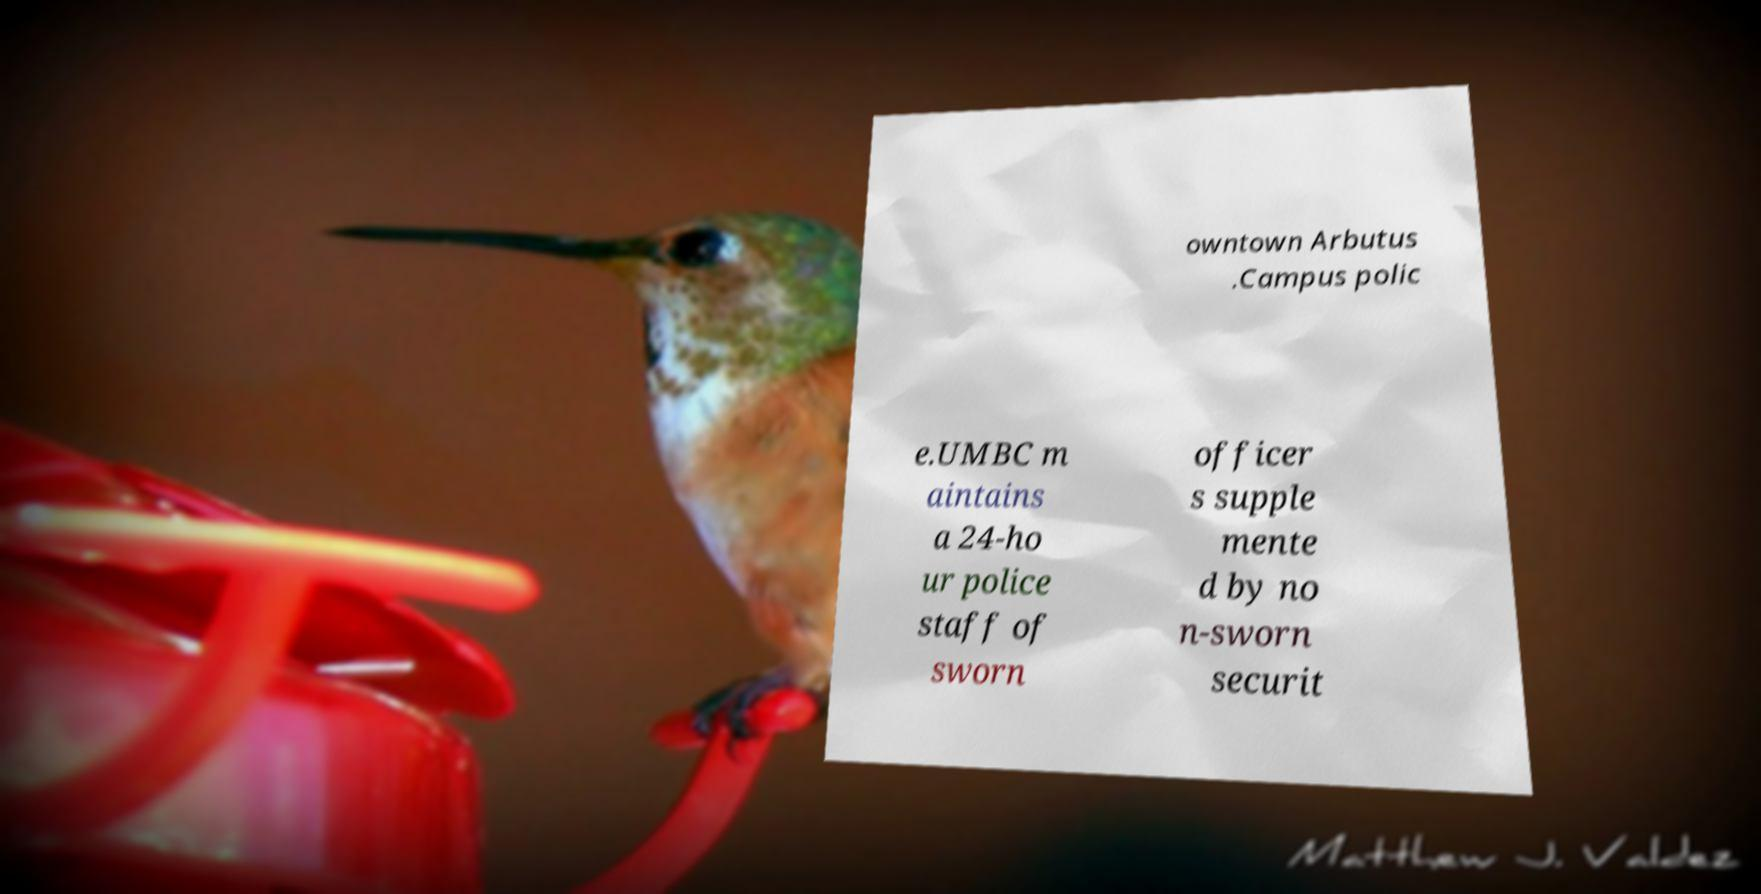Please identify and transcribe the text found in this image. owntown Arbutus .Campus polic e.UMBC m aintains a 24-ho ur police staff of sworn officer s supple mente d by no n-sworn securit 